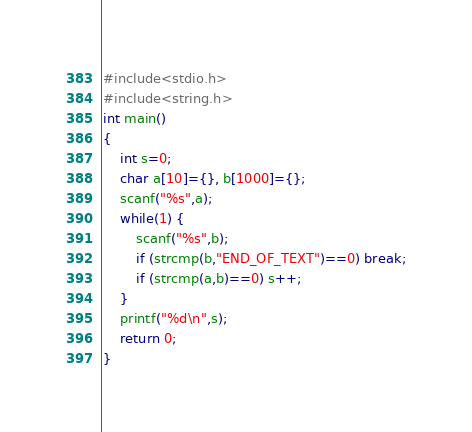Convert code to text. <code><loc_0><loc_0><loc_500><loc_500><_C_>#include<stdio.h>
#include<string.h>
int main()
{
	int s=0;
	char a[10]={}, b[1000]={};
	scanf("%s",a);
	while(1) {
		scanf("%s",b);
		if (strcmp(b,"END_OF_TEXT")==0) break;
		if (strcmp(a,b)==0) s++;
	}
	printf("%d\n",s);
	return 0;
}</code> 